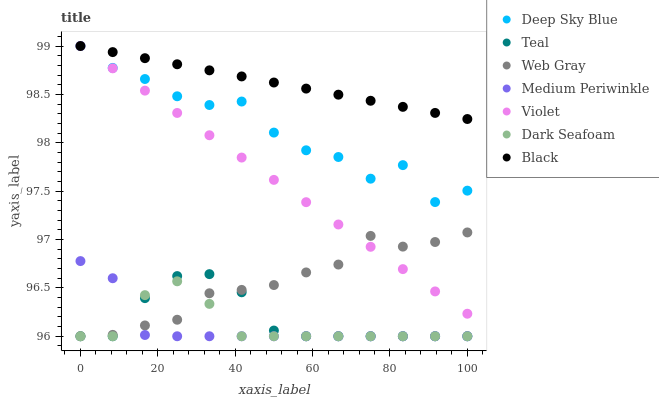Does Medium Periwinkle have the minimum area under the curve?
Answer yes or no. Yes. Does Black have the maximum area under the curve?
Answer yes or no. Yes. Does Deep Sky Blue have the minimum area under the curve?
Answer yes or no. No. Does Deep Sky Blue have the maximum area under the curve?
Answer yes or no. No. Is Violet the smoothest?
Answer yes or no. Yes. Is Deep Sky Blue the roughest?
Answer yes or no. Yes. Is Medium Periwinkle the smoothest?
Answer yes or no. No. Is Medium Periwinkle the roughest?
Answer yes or no. No. Does Web Gray have the lowest value?
Answer yes or no. Yes. Does Deep Sky Blue have the lowest value?
Answer yes or no. No. Does Violet have the highest value?
Answer yes or no. Yes. Does Medium Periwinkle have the highest value?
Answer yes or no. No. Is Dark Seafoam less than Violet?
Answer yes or no. Yes. Is Violet greater than Dark Seafoam?
Answer yes or no. Yes. Does Teal intersect Medium Periwinkle?
Answer yes or no. Yes. Is Teal less than Medium Periwinkle?
Answer yes or no. No. Is Teal greater than Medium Periwinkle?
Answer yes or no. No. Does Dark Seafoam intersect Violet?
Answer yes or no. No. 